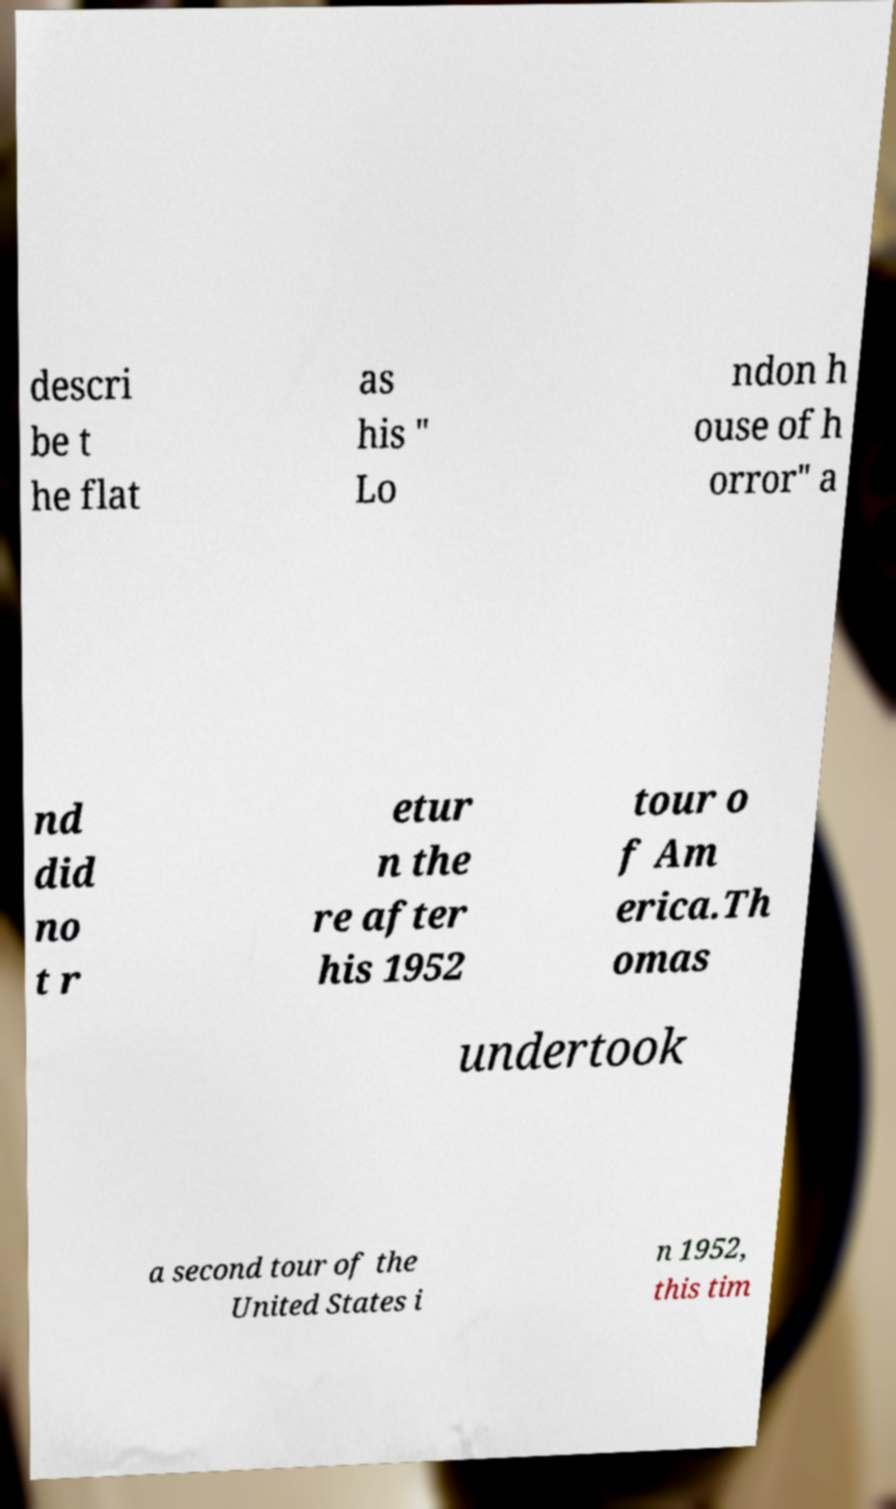I need the written content from this picture converted into text. Can you do that? descri be t he flat as his " Lo ndon h ouse of h orror" a nd did no t r etur n the re after his 1952 tour o f Am erica.Th omas undertook a second tour of the United States i n 1952, this tim 